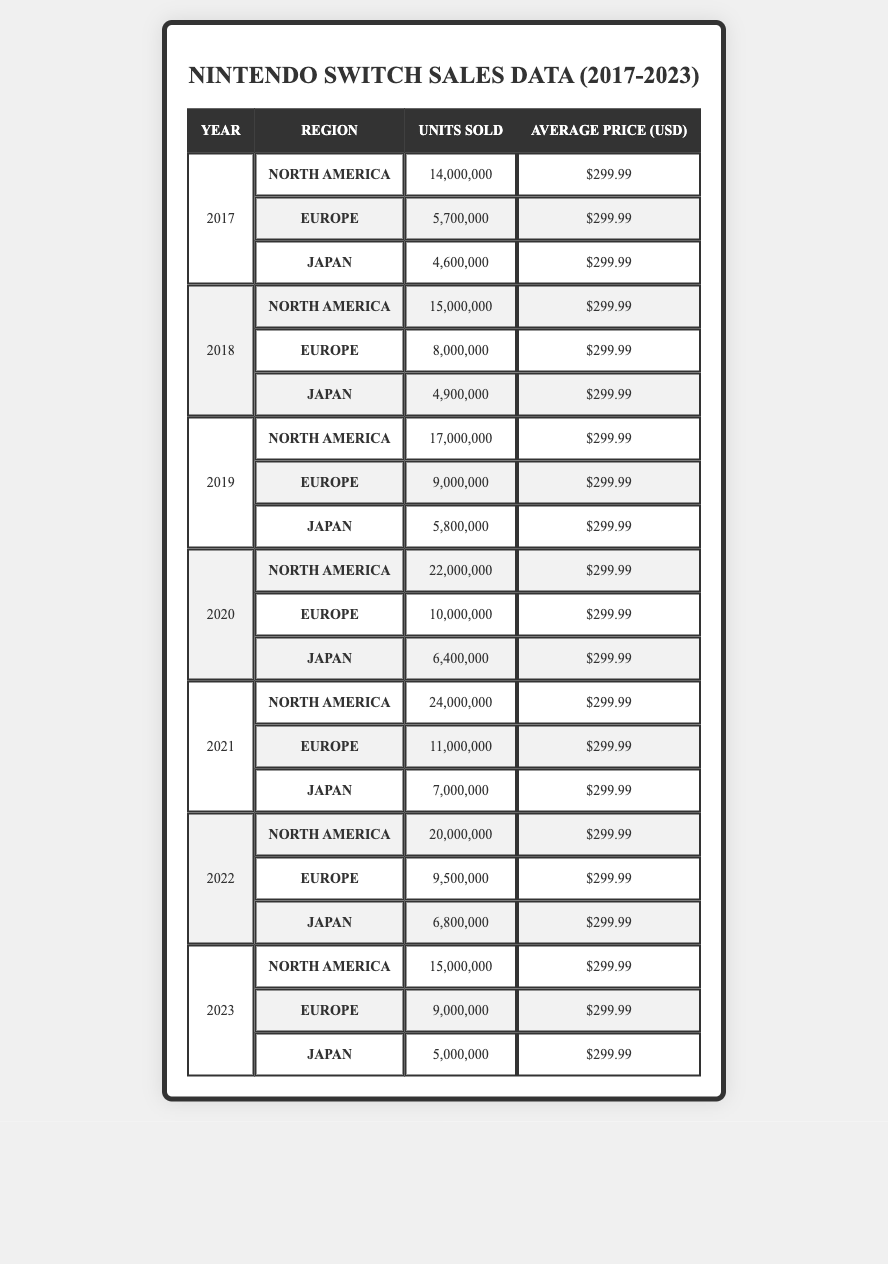What were the total units sold in North America in 2020? In 2020, North America sold 22,000,000 units according to the table.
Answer: 22,000,000 Which region had the highest sales in 2021? In 2021, North America sold 24,000,000 units, which is higher than Europe at 11,000,000 and Japan at 7,000,000.
Answer: North America What was the average number of units sold in Europe over the years 2017 to 2023? Europe sales over the years are: 5,700,000 (2017), 8,000,000 (2018), 9,000,000 (2019), 10,000,000 (2020), 11,000,000 (2021), 9,500,000 (2022), and 9,000,000 (2023). The total is 62,200,000, and dividing by 7 gives 8,885,714 (rounded).
Answer: Approximately 8,885,714 Did Japan sell more consoles in 2022 compared to 2023? In 2022, Japan sold 6,800,000 units while in 2023 it sold 5,000,000 units, so Japan sold more in 2022.
Answer: Yes What was the percentage increase in units sold from 2019 to 2020 in Europe? In 2019, Europe sold 9,000,000 units and in 2020 it sold 10,000,000 units. The increase is 10,000,000 - 9,000,000 = 1,000,000. The percentage increase is (1,000,000 / 9,000,000) * 100 = 11.11%.
Answer: 11.11% Which year had the lowest total sales across all regions? By summing the total sales across regions for each year, it can be seen that 2017 had the lowest sales (14,000,000 + 5,700,000 + 4,600,000 = 24,300,000). The following years had higher totals.
Answer: 2017 What is the trend of North America sales from 2017 to 2023? North America sales went from 14,000,000 in 2017 to 15,000,000 in 2023, peaking at 24,000,000 in 2021. The trend shows an initial increase up to 2021 and then a decrease.
Answer: Initial increase, then decrease How many more units did North America sell compared to Japan in 2020? North America sold 22,000,000 units, and Japan sold 6,400,000 units. The difference is 22,000,000 - 6,400,000 = 15,600,000 units more sold in North America.
Answer: 15,600,000 What was the total sales for Europe in 2022? Europe sold 9,500,000 units in 2022 according to the data in the table.
Answer: 9,500,000 In which year did Japan experience the highest sales? Japan's highest sales were in 2019 with 5,800,000 units sold.
Answer: 2019 What is the total number of units sold in all regions from 2017 to 2023? Summing all units sold across the years gives: 14,000,000 + 5,700,000 + 4,600,000 + 15,000,000 + 8,000,000 + 4,900,000 + 17,000,000 + 9,000,000 + 5,800,000 + 22,000,000 + 10,000,000 + 6,400,000 + 24,000,000 + 11,000,000 + 7,000,000 + 20,000,000 + 9,500,000 + 6,800,000 + 15,000,000 + 9,000,000 + 5,000,000 = 172,100,000.
Answer: 172,100,000 